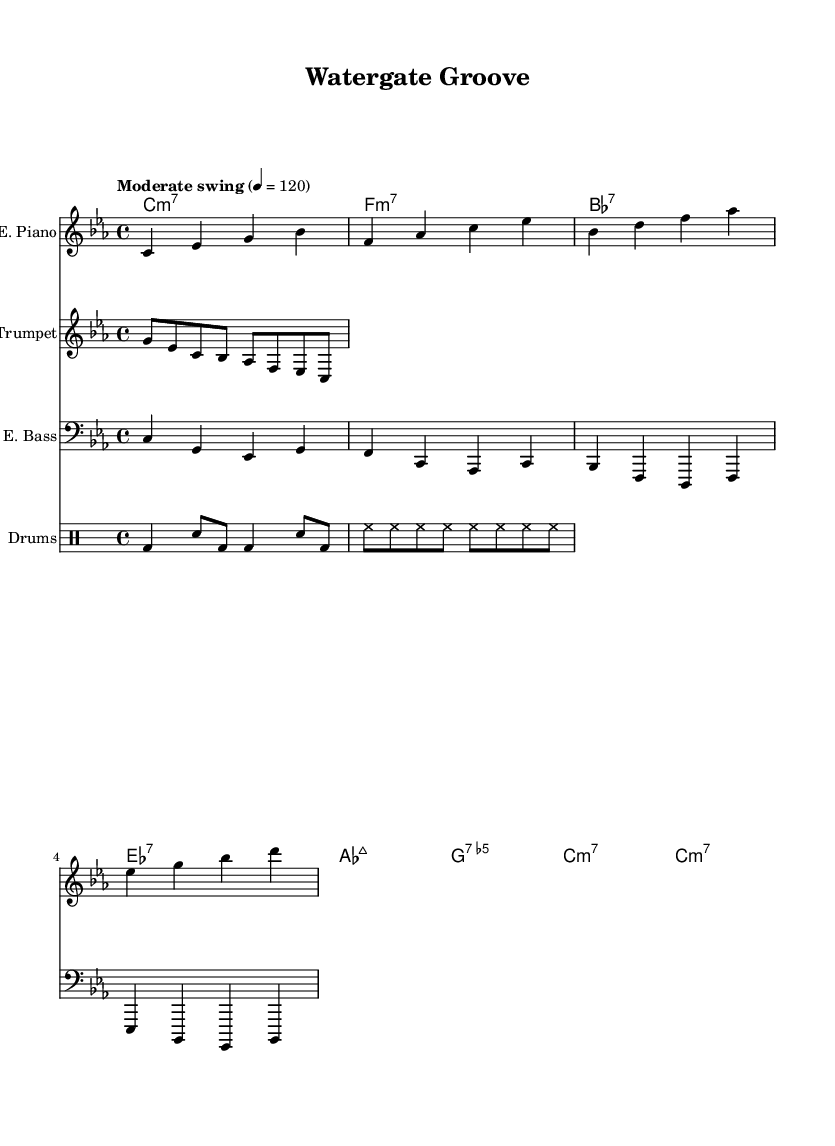What is the key signature of this music? The key signature is C minor, which has three flats (B♭, E♭, A♭). This is indicated at the beginning of the score.
Answer: C minor What is the time signature for this piece? The time signature is indicated at the beginning of the sheet music as 4/4, which means there are four beats in a measure and the quarter note gets one beat.
Answer: 4/4 What is the tempo marking for this piece? The tempo marking states "Moderate swing," which describes the feel and pace of the performance. The actual metronome marking provided is 120 beats per minute.
Answer: Moderate swing Which instruments are featured in this score? The score includes an electric piano, trumpet, electric bass, and drums. These instruments are indicated at the start of each staff in the score.
Answer: Electric piano, trumpet, electric bass, drums What is the first chord in the chord progression? The first chord in the progression is C minor 7. This is shown in the chord names section at the beginning of the score.
Answer: C minor 7 What rhythm pattern is used for the drums? The drum pattern consists of a bass drum and snare beats followed by hi-hat hits, indicating a common jazz style. The pattern reflects the swing feel typical in jazz drumming.
Answer: Bass and snare pattern 